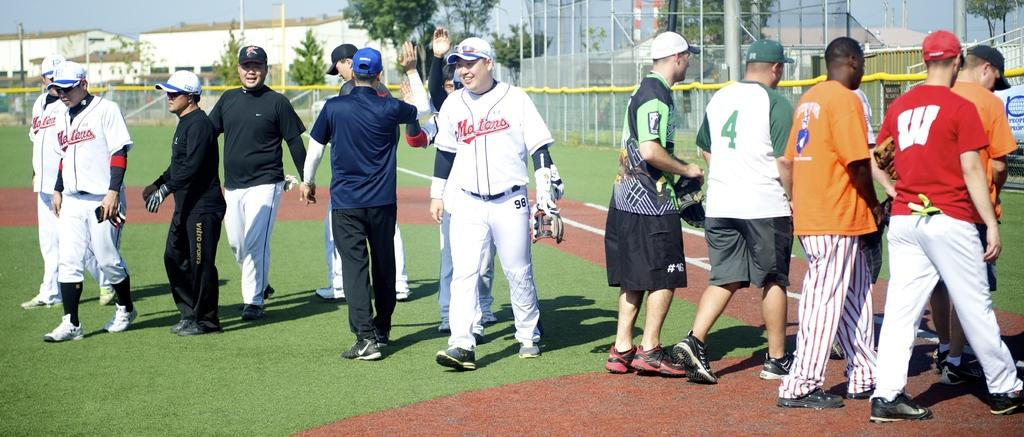<image>
Present a compact description of the photo's key features. Amongst the group of people with their backs turned one person is wearing a shirt with the number 4 printed upon it. 